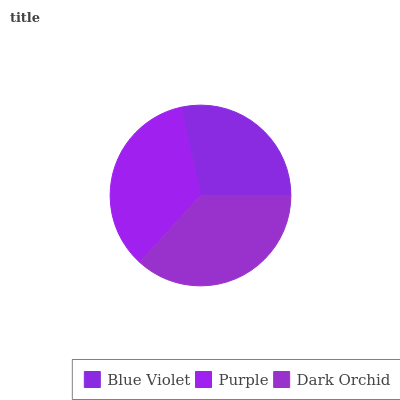Is Blue Violet the minimum?
Answer yes or no. Yes. Is Dark Orchid the maximum?
Answer yes or no. Yes. Is Purple the minimum?
Answer yes or no. No. Is Purple the maximum?
Answer yes or no. No. Is Purple greater than Blue Violet?
Answer yes or no. Yes. Is Blue Violet less than Purple?
Answer yes or no. Yes. Is Blue Violet greater than Purple?
Answer yes or no. No. Is Purple less than Blue Violet?
Answer yes or no. No. Is Purple the high median?
Answer yes or no. Yes. Is Purple the low median?
Answer yes or no. Yes. Is Dark Orchid the high median?
Answer yes or no. No. Is Blue Violet the low median?
Answer yes or no. No. 